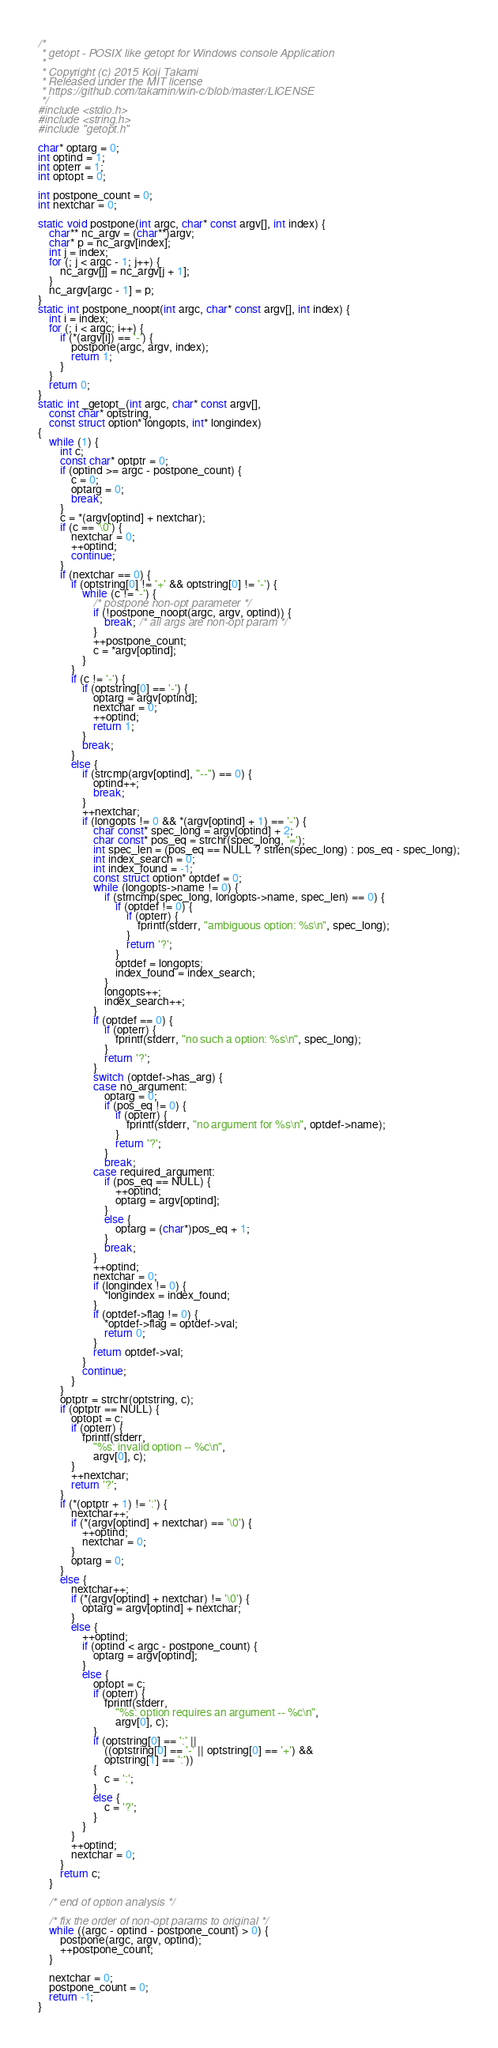Convert code to text. <code><loc_0><loc_0><loc_500><loc_500><_C_>/*
 * getopt - POSIX like getopt for Windows console Application
 *
 * Copyright (c) 2015 Koji Takami
 * Released under the MIT license
 * https://github.com/takamin/win-c/blob/master/LICENSE
 */
#include <stdio.h>
#include <string.h>
#include "getopt.h"

char* optarg = 0;
int optind = 1;
int opterr = 1;
int optopt = 0;

int postpone_count = 0;
int nextchar = 0;

static void postpone(int argc, char* const argv[], int index) {
    char** nc_argv = (char**)argv;
    char* p = nc_argv[index];
    int j = index;
    for (; j < argc - 1; j++) {
        nc_argv[j] = nc_argv[j + 1];
    }
    nc_argv[argc - 1] = p;
}
static int postpone_noopt(int argc, char* const argv[], int index) {
    int i = index;
    for (; i < argc; i++) {
        if (*(argv[i]) == '-') {
            postpone(argc, argv, index);
            return 1;
        }
    }
    return 0;
}
static int _getopt_(int argc, char* const argv[],
    const char* optstring,
    const struct option* longopts, int* longindex)
{
    while (1) {
        int c;
        const char* optptr = 0;
        if (optind >= argc - postpone_count) {
            c = 0;
            optarg = 0;
            break;
        }
        c = *(argv[optind] + nextchar);
        if (c == '\0') {
            nextchar = 0;
            ++optind;
            continue;
        }
        if (nextchar == 0) {
            if (optstring[0] != '+' && optstring[0] != '-') {
                while (c != '-') {
                    /* postpone non-opt parameter */
                    if (!postpone_noopt(argc, argv, optind)) {
                        break; /* all args are non-opt param */
                    }
                    ++postpone_count;
                    c = *argv[optind];
                }
            }
            if (c != '-') {
                if (optstring[0] == '-') {
                    optarg = argv[optind];
                    nextchar = 0;
                    ++optind;
                    return 1;
                }
                break;
            }
            else {
                if (strcmp(argv[optind], "--") == 0) {
                    optind++;
                    break;
                }
                ++nextchar;
                if (longopts != 0 && *(argv[optind] + 1) == '-') {
                    char const* spec_long = argv[optind] + 2;
                    char const* pos_eq = strchr(spec_long, '=');
                    int spec_len = (pos_eq == NULL ? strlen(spec_long) : pos_eq - spec_long);
                    int index_search = 0;
                    int index_found = -1;
                    const struct option* optdef = 0;
                    while (longopts->name != 0) {
                        if (strncmp(spec_long, longopts->name, spec_len) == 0) {
                            if (optdef != 0) {
                                if (opterr) {
                                    fprintf(stderr, "ambiguous option: %s\n", spec_long);
                                }
                                return '?';
                            }
                            optdef = longopts;
                            index_found = index_search;
                        }
                        longopts++;
                        index_search++;
                    }
                    if (optdef == 0) {
                        if (opterr) {
                            fprintf(stderr, "no such a option: %s\n", spec_long);
                        }
                        return '?';
                    }
                    switch (optdef->has_arg) {
                    case no_argument:
                        optarg = 0;
                        if (pos_eq != 0) {
                            if (opterr) {
                                fprintf(stderr, "no argument for %s\n", optdef->name);
                            }
                            return '?';
                        }
                        break;
                    case required_argument:
                        if (pos_eq == NULL) {
                            ++optind;
                            optarg = argv[optind];
                        }
                        else {
                            optarg = (char*)pos_eq + 1;
                        }
                        break;
                    }
                    ++optind;
                    nextchar = 0;
                    if (longindex != 0) {
                        *longindex = index_found;
                    }
                    if (optdef->flag != 0) {
                        *optdef->flag = optdef->val;
                        return 0;
                    }
                    return optdef->val;
                }
                continue;
            }
        }
        optptr = strchr(optstring, c);
        if (optptr == NULL) {
            optopt = c;
            if (opterr) {
                fprintf(stderr,
                    "%s: invalid option -- %c\n",
                    argv[0], c);
            }
            ++nextchar;
            return '?';
        }
        if (*(optptr + 1) != ':') {
            nextchar++;
            if (*(argv[optind] + nextchar) == '\0') {
                ++optind;
                nextchar = 0;
            }
            optarg = 0;
        }
        else {
            nextchar++;
            if (*(argv[optind] + nextchar) != '\0') {
                optarg = argv[optind] + nextchar;
            }
            else {
                ++optind;
                if (optind < argc - postpone_count) {
                    optarg = argv[optind];
                }
                else {
                    optopt = c;
                    if (opterr) {
                        fprintf(stderr,
                            "%s: option requires an argument -- %c\n",
                            argv[0], c);
                    }
                    if (optstring[0] == ':' ||
                        ((optstring[0] == '-' || optstring[0] == '+') &&
                        optstring[1] == ':'))
                    {
                        c = ':';
                    }
                    else {
                        c = '?';
                    }
                }
            }
            ++optind;
            nextchar = 0;
        }
        return c;
    }

    /* end of option analysis */

    /* fix the order of non-opt params to original */
    while ((argc - optind - postpone_count) > 0) {
        postpone(argc, argv, optind);
        ++postpone_count;
    }

    nextchar = 0;
    postpone_count = 0;
    return -1;
}
</code> 